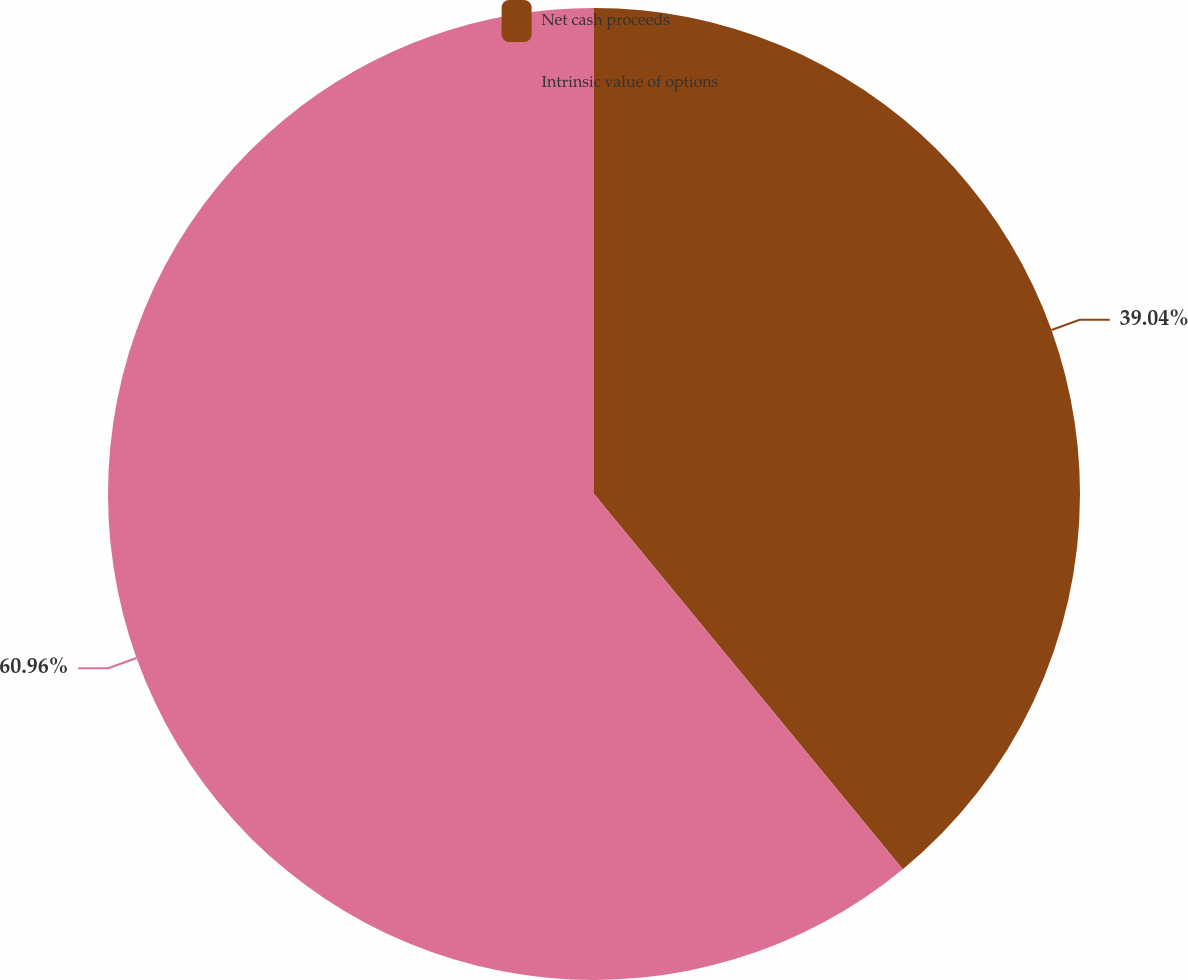Convert chart to OTSL. <chart><loc_0><loc_0><loc_500><loc_500><pie_chart><fcel>Net cash proceeds<fcel>Intrinsic value of options<nl><fcel>39.04%<fcel>60.96%<nl></chart> 